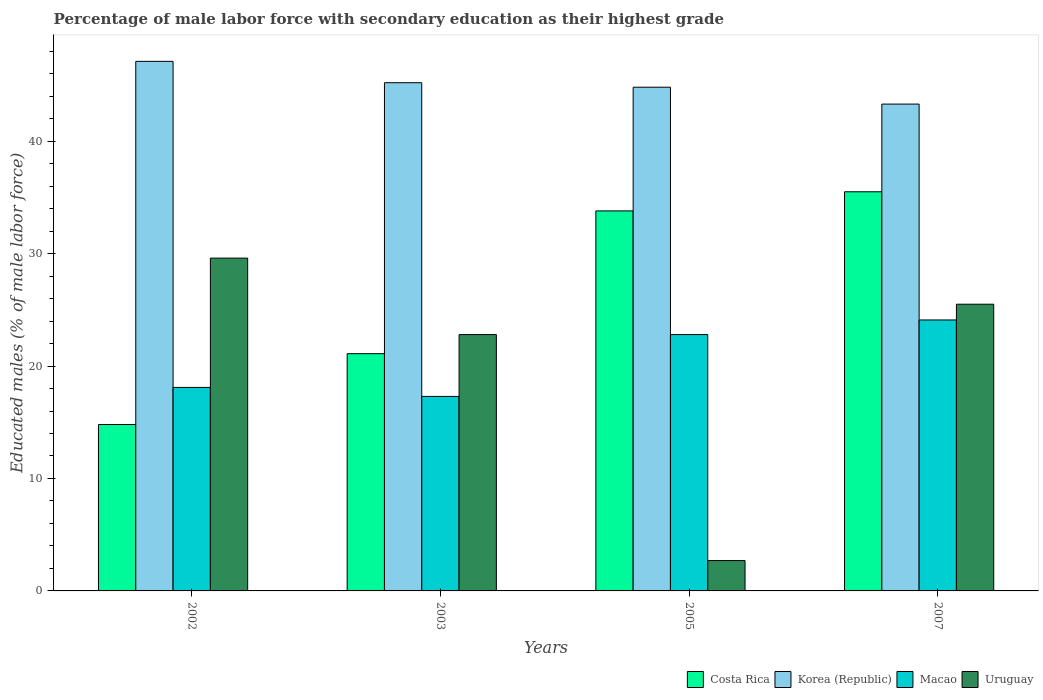How many groups of bars are there?
Make the answer very short. 4. Are the number of bars on each tick of the X-axis equal?
Provide a short and direct response. Yes. What is the label of the 4th group of bars from the left?
Offer a terse response. 2007. In how many cases, is the number of bars for a given year not equal to the number of legend labels?
Ensure brevity in your answer.  0. What is the percentage of male labor force with secondary education in Costa Rica in 2005?
Your answer should be compact. 33.8. Across all years, what is the maximum percentage of male labor force with secondary education in Uruguay?
Keep it short and to the point. 29.6. Across all years, what is the minimum percentage of male labor force with secondary education in Macao?
Offer a very short reply. 17.3. In which year was the percentage of male labor force with secondary education in Korea (Republic) maximum?
Provide a succinct answer. 2002. In which year was the percentage of male labor force with secondary education in Costa Rica minimum?
Your answer should be compact. 2002. What is the total percentage of male labor force with secondary education in Uruguay in the graph?
Give a very brief answer. 80.6. What is the difference between the percentage of male labor force with secondary education in Korea (Republic) in 2002 and that in 2007?
Your response must be concise. 3.8. What is the difference between the percentage of male labor force with secondary education in Macao in 2005 and the percentage of male labor force with secondary education in Korea (Republic) in 2002?
Give a very brief answer. -24.3. What is the average percentage of male labor force with secondary education in Uruguay per year?
Ensure brevity in your answer.  20.15. In the year 2005, what is the difference between the percentage of male labor force with secondary education in Uruguay and percentage of male labor force with secondary education in Macao?
Provide a short and direct response. -20.1. What is the ratio of the percentage of male labor force with secondary education in Korea (Republic) in 2002 to that in 2007?
Offer a terse response. 1.09. What is the difference between the highest and the second highest percentage of male labor force with secondary education in Korea (Republic)?
Provide a succinct answer. 1.9. What is the difference between the highest and the lowest percentage of male labor force with secondary education in Costa Rica?
Keep it short and to the point. 20.7. Is the sum of the percentage of male labor force with secondary education in Costa Rica in 2002 and 2007 greater than the maximum percentage of male labor force with secondary education in Macao across all years?
Provide a short and direct response. Yes. Is it the case that in every year, the sum of the percentage of male labor force with secondary education in Macao and percentage of male labor force with secondary education in Korea (Republic) is greater than the sum of percentage of male labor force with secondary education in Uruguay and percentage of male labor force with secondary education in Costa Rica?
Make the answer very short. Yes. What does the 4th bar from the left in 2005 represents?
Provide a succinct answer. Uruguay. What does the 2nd bar from the right in 2003 represents?
Make the answer very short. Macao. How many bars are there?
Provide a succinct answer. 16. Are all the bars in the graph horizontal?
Offer a very short reply. No. Are the values on the major ticks of Y-axis written in scientific E-notation?
Make the answer very short. No. Does the graph contain grids?
Ensure brevity in your answer.  No. How many legend labels are there?
Your answer should be very brief. 4. What is the title of the graph?
Your answer should be compact. Percentage of male labor force with secondary education as their highest grade. What is the label or title of the X-axis?
Your answer should be very brief. Years. What is the label or title of the Y-axis?
Your answer should be very brief. Educated males (% of male labor force). What is the Educated males (% of male labor force) of Costa Rica in 2002?
Make the answer very short. 14.8. What is the Educated males (% of male labor force) of Korea (Republic) in 2002?
Your answer should be very brief. 47.1. What is the Educated males (% of male labor force) of Macao in 2002?
Provide a succinct answer. 18.1. What is the Educated males (% of male labor force) in Uruguay in 2002?
Provide a succinct answer. 29.6. What is the Educated males (% of male labor force) in Costa Rica in 2003?
Give a very brief answer. 21.1. What is the Educated males (% of male labor force) in Korea (Republic) in 2003?
Provide a succinct answer. 45.2. What is the Educated males (% of male labor force) in Macao in 2003?
Provide a succinct answer. 17.3. What is the Educated males (% of male labor force) in Uruguay in 2003?
Provide a short and direct response. 22.8. What is the Educated males (% of male labor force) in Costa Rica in 2005?
Provide a succinct answer. 33.8. What is the Educated males (% of male labor force) of Korea (Republic) in 2005?
Provide a succinct answer. 44.8. What is the Educated males (% of male labor force) in Macao in 2005?
Your answer should be very brief. 22.8. What is the Educated males (% of male labor force) of Uruguay in 2005?
Your answer should be compact. 2.7. What is the Educated males (% of male labor force) in Costa Rica in 2007?
Your answer should be very brief. 35.5. What is the Educated males (% of male labor force) of Korea (Republic) in 2007?
Offer a very short reply. 43.3. What is the Educated males (% of male labor force) in Macao in 2007?
Ensure brevity in your answer.  24.1. Across all years, what is the maximum Educated males (% of male labor force) in Costa Rica?
Provide a short and direct response. 35.5. Across all years, what is the maximum Educated males (% of male labor force) of Korea (Republic)?
Keep it short and to the point. 47.1. Across all years, what is the maximum Educated males (% of male labor force) in Macao?
Give a very brief answer. 24.1. Across all years, what is the maximum Educated males (% of male labor force) in Uruguay?
Make the answer very short. 29.6. Across all years, what is the minimum Educated males (% of male labor force) in Costa Rica?
Offer a terse response. 14.8. Across all years, what is the minimum Educated males (% of male labor force) in Korea (Republic)?
Offer a very short reply. 43.3. Across all years, what is the minimum Educated males (% of male labor force) of Macao?
Give a very brief answer. 17.3. Across all years, what is the minimum Educated males (% of male labor force) in Uruguay?
Offer a terse response. 2.7. What is the total Educated males (% of male labor force) in Costa Rica in the graph?
Your answer should be compact. 105.2. What is the total Educated males (% of male labor force) of Korea (Republic) in the graph?
Offer a terse response. 180.4. What is the total Educated males (% of male labor force) of Macao in the graph?
Provide a short and direct response. 82.3. What is the total Educated males (% of male labor force) in Uruguay in the graph?
Offer a very short reply. 80.6. What is the difference between the Educated males (% of male labor force) of Uruguay in 2002 and that in 2003?
Keep it short and to the point. 6.8. What is the difference between the Educated males (% of male labor force) of Costa Rica in 2002 and that in 2005?
Make the answer very short. -19. What is the difference between the Educated males (% of male labor force) of Uruguay in 2002 and that in 2005?
Provide a short and direct response. 26.9. What is the difference between the Educated males (% of male labor force) in Costa Rica in 2002 and that in 2007?
Offer a very short reply. -20.7. What is the difference between the Educated males (% of male labor force) of Korea (Republic) in 2002 and that in 2007?
Provide a short and direct response. 3.8. What is the difference between the Educated males (% of male labor force) of Costa Rica in 2003 and that in 2005?
Provide a short and direct response. -12.7. What is the difference between the Educated males (% of male labor force) in Korea (Republic) in 2003 and that in 2005?
Give a very brief answer. 0.4. What is the difference between the Educated males (% of male labor force) of Uruguay in 2003 and that in 2005?
Give a very brief answer. 20.1. What is the difference between the Educated males (% of male labor force) of Costa Rica in 2003 and that in 2007?
Offer a very short reply. -14.4. What is the difference between the Educated males (% of male labor force) of Costa Rica in 2005 and that in 2007?
Your response must be concise. -1.7. What is the difference between the Educated males (% of male labor force) in Uruguay in 2005 and that in 2007?
Make the answer very short. -22.8. What is the difference between the Educated males (% of male labor force) of Costa Rica in 2002 and the Educated males (% of male labor force) of Korea (Republic) in 2003?
Make the answer very short. -30.4. What is the difference between the Educated males (% of male labor force) in Costa Rica in 2002 and the Educated males (% of male labor force) in Macao in 2003?
Ensure brevity in your answer.  -2.5. What is the difference between the Educated males (% of male labor force) of Korea (Republic) in 2002 and the Educated males (% of male labor force) of Macao in 2003?
Your response must be concise. 29.8. What is the difference between the Educated males (% of male labor force) of Korea (Republic) in 2002 and the Educated males (% of male labor force) of Uruguay in 2003?
Offer a terse response. 24.3. What is the difference between the Educated males (% of male labor force) of Macao in 2002 and the Educated males (% of male labor force) of Uruguay in 2003?
Give a very brief answer. -4.7. What is the difference between the Educated males (% of male labor force) in Costa Rica in 2002 and the Educated males (% of male labor force) in Uruguay in 2005?
Your response must be concise. 12.1. What is the difference between the Educated males (% of male labor force) in Korea (Republic) in 2002 and the Educated males (% of male labor force) in Macao in 2005?
Ensure brevity in your answer.  24.3. What is the difference between the Educated males (% of male labor force) of Korea (Republic) in 2002 and the Educated males (% of male labor force) of Uruguay in 2005?
Offer a terse response. 44.4. What is the difference between the Educated males (% of male labor force) in Costa Rica in 2002 and the Educated males (% of male labor force) in Korea (Republic) in 2007?
Ensure brevity in your answer.  -28.5. What is the difference between the Educated males (% of male labor force) of Korea (Republic) in 2002 and the Educated males (% of male labor force) of Macao in 2007?
Your answer should be very brief. 23. What is the difference between the Educated males (% of male labor force) in Korea (Republic) in 2002 and the Educated males (% of male labor force) in Uruguay in 2007?
Keep it short and to the point. 21.6. What is the difference between the Educated males (% of male labor force) of Costa Rica in 2003 and the Educated males (% of male labor force) of Korea (Republic) in 2005?
Your answer should be compact. -23.7. What is the difference between the Educated males (% of male labor force) in Costa Rica in 2003 and the Educated males (% of male labor force) in Macao in 2005?
Provide a short and direct response. -1.7. What is the difference between the Educated males (% of male labor force) of Costa Rica in 2003 and the Educated males (% of male labor force) of Uruguay in 2005?
Make the answer very short. 18.4. What is the difference between the Educated males (% of male labor force) of Korea (Republic) in 2003 and the Educated males (% of male labor force) of Macao in 2005?
Offer a very short reply. 22.4. What is the difference between the Educated males (% of male labor force) in Korea (Republic) in 2003 and the Educated males (% of male labor force) in Uruguay in 2005?
Your answer should be compact. 42.5. What is the difference between the Educated males (% of male labor force) in Costa Rica in 2003 and the Educated males (% of male labor force) in Korea (Republic) in 2007?
Give a very brief answer. -22.2. What is the difference between the Educated males (% of male labor force) of Costa Rica in 2003 and the Educated males (% of male labor force) of Uruguay in 2007?
Make the answer very short. -4.4. What is the difference between the Educated males (% of male labor force) of Korea (Republic) in 2003 and the Educated males (% of male labor force) of Macao in 2007?
Offer a very short reply. 21.1. What is the difference between the Educated males (% of male labor force) of Korea (Republic) in 2003 and the Educated males (% of male labor force) of Uruguay in 2007?
Keep it short and to the point. 19.7. What is the difference between the Educated males (% of male labor force) in Macao in 2003 and the Educated males (% of male labor force) in Uruguay in 2007?
Offer a very short reply. -8.2. What is the difference between the Educated males (% of male labor force) of Korea (Republic) in 2005 and the Educated males (% of male labor force) of Macao in 2007?
Offer a terse response. 20.7. What is the difference between the Educated males (% of male labor force) in Korea (Republic) in 2005 and the Educated males (% of male labor force) in Uruguay in 2007?
Your answer should be compact. 19.3. What is the difference between the Educated males (% of male labor force) of Macao in 2005 and the Educated males (% of male labor force) of Uruguay in 2007?
Give a very brief answer. -2.7. What is the average Educated males (% of male labor force) in Costa Rica per year?
Keep it short and to the point. 26.3. What is the average Educated males (% of male labor force) of Korea (Republic) per year?
Your response must be concise. 45.1. What is the average Educated males (% of male labor force) of Macao per year?
Make the answer very short. 20.57. What is the average Educated males (% of male labor force) in Uruguay per year?
Offer a terse response. 20.15. In the year 2002, what is the difference between the Educated males (% of male labor force) in Costa Rica and Educated males (% of male labor force) in Korea (Republic)?
Make the answer very short. -32.3. In the year 2002, what is the difference between the Educated males (% of male labor force) in Costa Rica and Educated males (% of male labor force) in Uruguay?
Ensure brevity in your answer.  -14.8. In the year 2002, what is the difference between the Educated males (% of male labor force) of Korea (Republic) and Educated males (% of male labor force) of Uruguay?
Keep it short and to the point. 17.5. In the year 2002, what is the difference between the Educated males (% of male labor force) of Macao and Educated males (% of male labor force) of Uruguay?
Keep it short and to the point. -11.5. In the year 2003, what is the difference between the Educated males (% of male labor force) of Costa Rica and Educated males (% of male labor force) of Korea (Republic)?
Keep it short and to the point. -24.1. In the year 2003, what is the difference between the Educated males (% of male labor force) of Costa Rica and Educated males (% of male labor force) of Macao?
Provide a succinct answer. 3.8. In the year 2003, what is the difference between the Educated males (% of male labor force) of Costa Rica and Educated males (% of male labor force) of Uruguay?
Keep it short and to the point. -1.7. In the year 2003, what is the difference between the Educated males (% of male labor force) of Korea (Republic) and Educated males (% of male labor force) of Macao?
Provide a succinct answer. 27.9. In the year 2003, what is the difference between the Educated males (% of male labor force) of Korea (Republic) and Educated males (% of male labor force) of Uruguay?
Provide a short and direct response. 22.4. In the year 2003, what is the difference between the Educated males (% of male labor force) in Macao and Educated males (% of male labor force) in Uruguay?
Give a very brief answer. -5.5. In the year 2005, what is the difference between the Educated males (% of male labor force) in Costa Rica and Educated males (% of male labor force) in Macao?
Make the answer very short. 11. In the year 2005, what is the difference between the Educated males (% of male labor force) of Costa Rica and Educated males (% of male labor force) of Uruguay?
Make the answer very short. 31.1. In the year 2005, what is the difference between the Educated males (% of male labor force) in Korea (Republic) and Educated males (% of male labor force) in Macao?
Ensure brevity in your answer.  22. In the year 2005, what is the difference between the Educated males (% of male labor force) of Korea (Republic) and Educated males (% of male labor force) of Uruguay?
Keep it short and to the point. 42.1. In the year 2005, what is the difference between the Educated males (% of male labor force) of Macao and Educated males (% of male labor force) of Uruguay?
Give a very brief answer. 20.1. In the year 2007, what is the difference between the Educated males (% of male labor force) of Costa Rica and Educated males (% of male labor force) of Korea (Republic)?
Offer a terse response. -7.8. In the year 2007, what is the difference between the Educated males (% of male labor force) of Macao and Educated males (% of male labor force) of Uruguay?
Offer a terse response. -1.4. What is the ratio of the Educated males (% of male labor force) in Costa Rica in 2002 to that in 2003?
Give a very brief answer. 0.7. What is the ratio of the Educated males (% of male labor force) of Korea (Republic) in 2002 to that in 2003?
Your response must be concise. 1.04. What is the ratio of the Educated males (% of male labor force) in Macao in 2002 to that in 2003?
Make the answer very short. 1.05. What is the ratio of the Educated males (% of male labor force) of Uruguay in 2002 to that in 2003?
Provide a succinct answer. 1.3. What is the ratio of the Educated males (% of male labor force) of Costa Rica in 2002 to that in 2005?
Your response must be concise. 0.44. What is the ratio of the Educated males (% of male labor force) in Korea (Republic) in 2002 to that in 2005?
Keep it short and to the point. 1.05. What is the ratio of the Educated males (% of male labor force) of Macao in 2002 to that in 2005?
Give a very brief answer. 0.79. What is the ratio of the Educated males (% of male labor force) in Uruguay in 2002 to that in 2005?
Your answer should be very brief. 10.96. What is the ratio of the Educated males (% of male labor force) in Costa Rica in 2002 to that in 2007?
Give a very brief answer. 0.42. What is the ratio of the Educated males (% of male labor force) in Korea (Republic) in 2002 to that in 2007?
Your answer should be compact. 1.09. What is the ratio of the Educated males (% of male labor force) of Macao in 2002 to that in 2007?
Your answer should be compact. 0.75. What is the ratio of the Educated males (% of male labor force) of Uruguay in 2002 to that in 2007?
Your answer should be very brief. 1.16. What is the ratio of the Educated males (% of male labor force) in Costa Rica in 2003 to that in 2005?
Make the answer very short. 0.62. What is the ratio of the Educated males (% of male labor force) in Korea (Republic) in 2003 to that in 2005?
Give a very brief answer. 1.01. What is the ratio of the Educated males (% of male labor force) of Macao in 2003 to that in 2005?
Give a very brief answer. 0.76. What is the ratio of the Educated males (% of male labor force) in Uruguay in 2003 to that in 2005?
Provide a short and direct response. 8.44. What is the ratio of the Educated males (% of male labor force) in Costa Rica in 2003 to that in 2007?
Provide a short and direct response. 0.59. What is the ratio of the Educated males (% of male labor force) in Korea (Republic) in 2003 to that in 2007?
Ensure brevity in your answer.  1.04. What is the ratio of the Educated males (% of male labor force) in Macao in 2003 to that in 2007?
Your response must be concise. 0.72. What is the ratio of the Educated males (% of male labor force) in Uruguay in 2003 to that in 2007?
Provide a succinct answer. 0.89. What is the ratio of the Educated males (% of male labor force) of Costa Rica in 2005 to that in 2007?
Offer a very short reply. 0.95. What is the ratio of the Educated males (% of male labor force) in Korea (Republic) in 2005 to that in 2007?
Your answer should be very brief. 1.03. What is the ratio of the Educated males (% of male labor force) of Macao in 2005 to that in 2007?
Provide a short and direct response. 0.95. What is the ratio of the Educated males (% of male labor force) in Uruguay in 2005 to that in 2007?
Offer a terse response. 0.11. What is the difference between the highest and the second highest Educated males (% of male labor force) of Costa Rica?
Offer a very short reply. 1.7. What is the difference between the highest and the second highest Educated males (% of male labor force) of Korea (Republic)?
Provide a short and direct response. 1.9. What is the difference between the highest and the lowest Educated males (% of male labor force) of Costa Rica?
Your answer should be very brief. 20.7. What is the difference between the highest and the lowest Educated males (% of male labor force) in Macao?
Your answer should be very brief. 6.8. What is the difference between the highest and the lowest Educated males (% of male labor force) in Uruguay?
Make the answer very short. 26.9. 